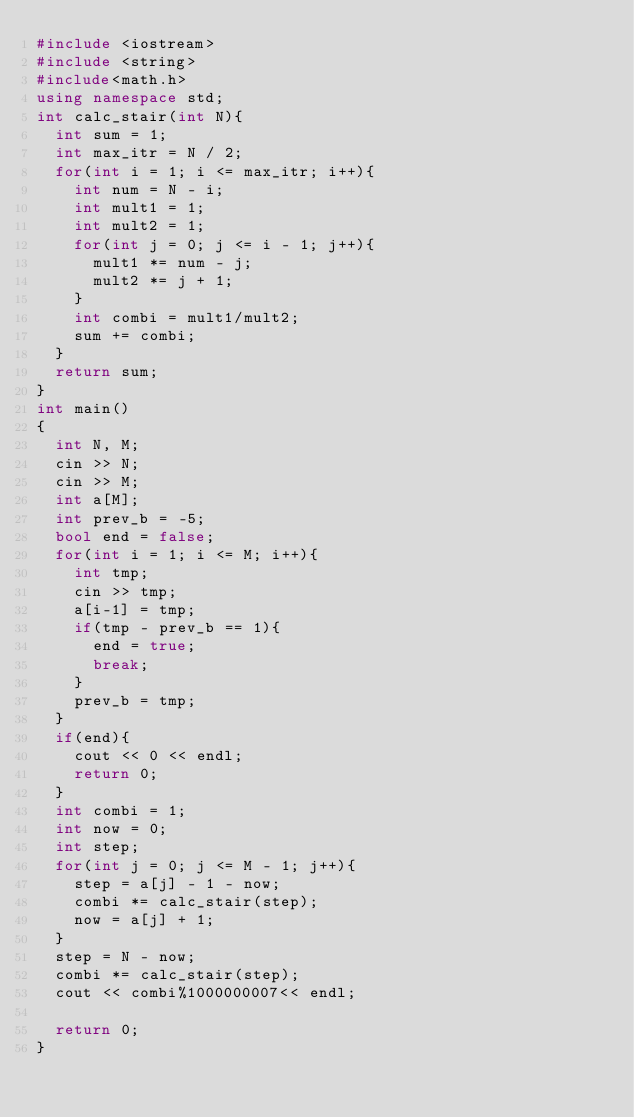Convert code to text. <code><loc_0><loc_0><loc_500><loc_500><_C++_>#include <iostream>
#include <string>
#include<math.h>
using namespace std;
int calc_stair(int N){
  int sum = 1;
  int max_itr = N / 2;
  for(int i = 1; i <= max_itr; i++){
    int num = N - i;
    int mult1 = 1;
    int mult2 = 1;
    for(int j = 0; j <= i - 1; j++){
      mult1 *= num - j;
      mult2 *= j + 1;
    }
    int combi = mult1/mult2;
    sum += combi;
  }
  return sum;
}
int main()
{
  int N, M;
  cin >> N;
  cin >> M;
  int a[M];
  int prev_b = -5;
  bool end = false;
  for(int i = 1; i <= M; i++){
    int tmp;
    cin >> tmp;
    a[i-1] = tmp;
    if(tmp - prev_b == 1){
      end = true;
      break;
    }
    prev_b = tmp;
  }
  if(end){
    cout << 0 << endl;
    return 0;
  }
  int combi = 1;
  int now = 0;
  int step;
  for(int j = 0; j <= M - 1; j++){
    step = a[j] - 1 - now;
    combi *= calc_stair(step);
    now = a[j] + 1;
  }
  step = N - now;
  combi *= calc_stair(step);
  cout << combi%1000000007<< endl;

  return 0;
}
</code> 